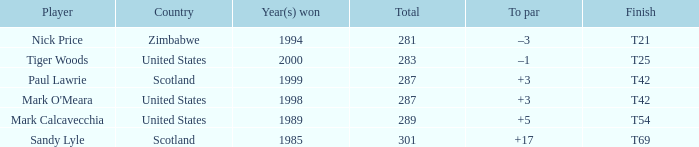How does tiger woods' score compare to par? –1. 